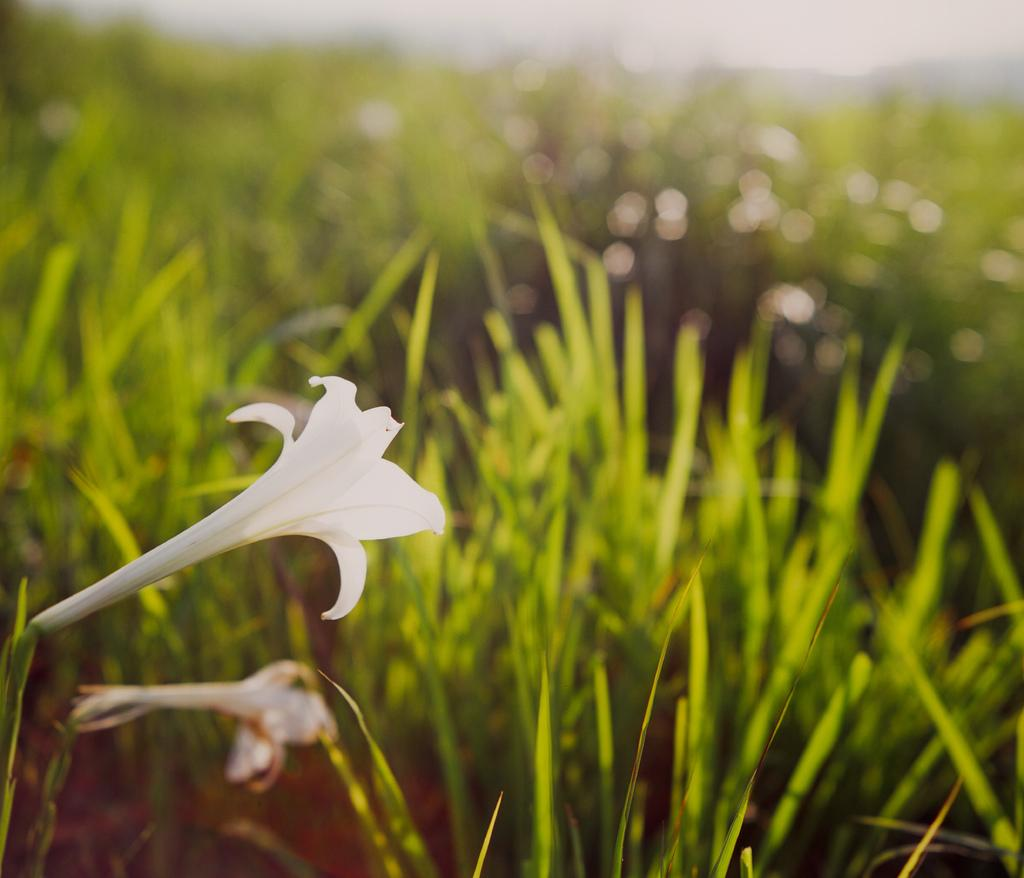How many flowers can be seen in the image? There are two flowers in the image. What type of vegetation is present in the image besides the flowers? There is grass in the image. Can you describe the background of the image? The background of the image is blurred. What time of day is depicted in the image, and how is it measured? The time of day cannot be determined from the image, and there is no clock or hour-measuring device present. 